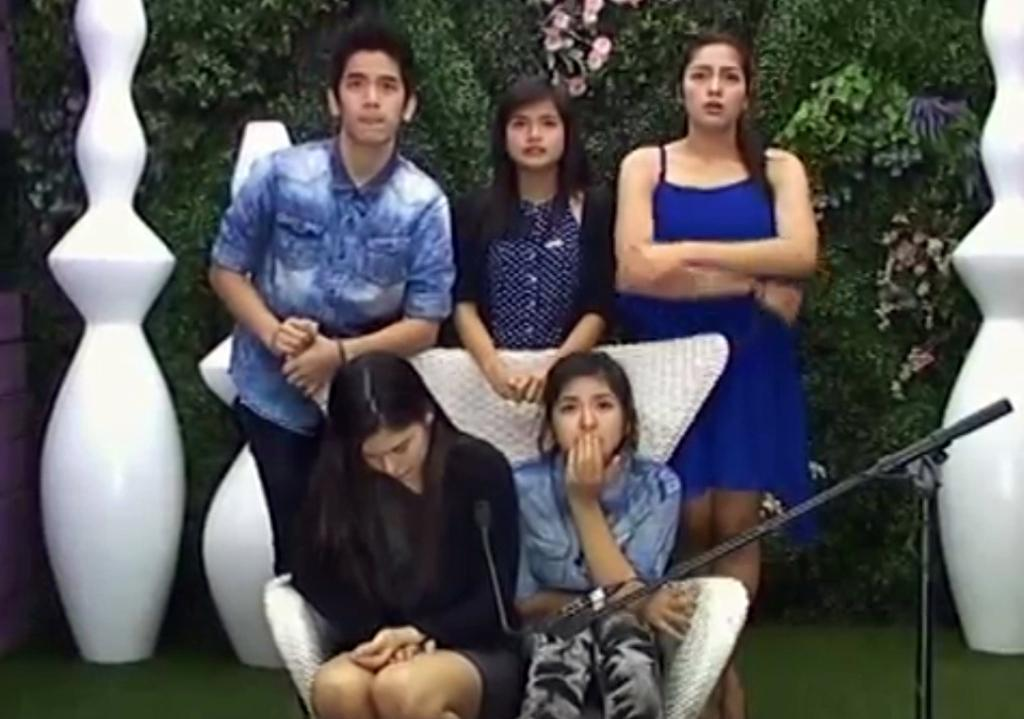How many girls are sitting in the image? There are two girls sitting in the image. How many girls are standing in the image? There are two girls standing in the image, one on the right side and one on the left side. How many boys are standing in the image? There is one boy standing in the image. What type of knowledge is the boy sharing with the girls in the image? There is no indication in the image that the boy is sharing any knowledge with the girls. What color is the shirt of the girl on the left side? The provided facts do not mention the color of any shirts, so we cannot determine the color of the girl's shirt on the left side. 